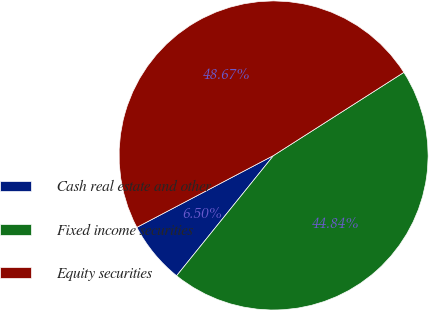<chart> <loc_0><loc_0><loc_500><loc_500><pie_chart><fcel>Cash real estate and other<fcel>Fixed income securities<fcel>Equity securities<nl><fcel>6.5%<fcel>44.84%<fcel>48.67%<nl></chart> 